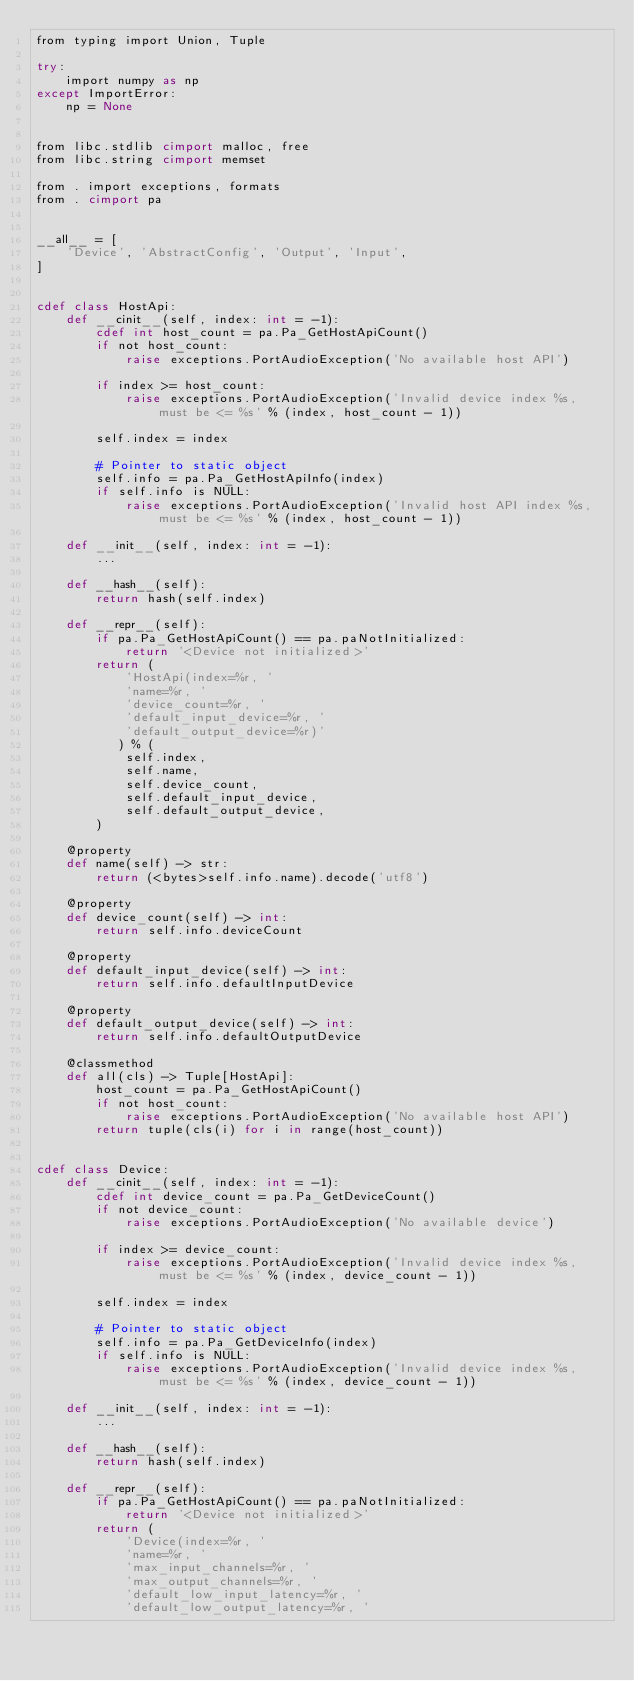<code> <loc_0><loc_0><loc_500><loc_500><_Cython_>from typing import Union, Tuple

try:
    import numpy as np
except ImportError:
    np = None


from libc.stdlib cimport malloc, free
from libc.string cimport memset

from . import exceptions, formats
from . cimport pa


__all__ = [
    'Device', 'AbstractConfig', 'Output', 'Input',
]


cdef class HostApi:
    def __cinit__(self, index: int = -1):
        cdef int host_count = pa.Pa_GetHostApiCount()
        if not host_count:
            raise exceptions.PortAudioException('No available host API')

        if index >= host_count:
            raise exceptions.PortAudioException('Invalid device index %s, must be <= %s' % (index, host_count - 1))

        self.index = index

        # Pointer to static object
        self.info = pa.Pa_GetHostApiInfo(index)
        if self.info is NULL:
            raise exceptions.PortAudioException('Invalid host API index %s, must be <= %s' % (index, host_count - 1))

    def __init__(self, index: int = -1):
        ...

    def __hash__(self):
        return hash(self.index)

    def __repr__(self):
        if pa.Pa_GetHostApiCount() == pa.paNotInitialized:
            return '<Device not initialized>'
        return (
            'HostApi(index=%r, '
            'name=%r, '
            'device_count=%r, '
            'default_input_device=%r, '
            'default_output_device=%r)'
           ) % (
            self.index,
            self.name,
            self.device_count,
            self.default_input_device,
            self.default_output_device,
        )

    @property
    def name(self) -> str:
        return (<bytes>self.info.name).decode('utf8')

    @property
    def device_count(self) -> int:
        return self.info.deviceCount

    @property
    def default_input_device(self) -> int:
        return self.info.defaultInputDevice

    @property
    def default_output_device(self) -> int:
        return self.info.defaultOutputDevice

    @classmethod
    def all(cls) -> Tuple[HostApi]:
        host_count = pa.Pa_GetHostApiCount()
        if not host_count:
            raise exceptions.PortAudioException('No available host API')
        return tuple(cls(i) for i in range(host_count))


cdef class Device:
    def __cinit__(self, index: int = -1):
        cdef int device_count = pa.Pa_GetDeviceCount()
        if not device_count:
            raise exceptions.PortAudioException('No available device')

        if index >= device_count:
            raise exceptions.PortAudioException('Invalid device index %s, must be <= %s' % (index, device_count - 1))

        self.index = index

        # Pointer to static object
        self.info = pa.Pa_GetDeviceInfo(index)
        if self.info is NULL:
            raise exceptions.PortAudioException('Invalid device index %s, must be <= %s' % (index, device_count - 1))

    def __init__(self, index: int = -1):
        ...

    def __hash__(self):
        return hash(self.index)

    def __repr__(self):
        if pa.Pa_GetHostApiCount() == pa.paNotInitialized:
            return '<Device not initialized>'
        return (
            'Device(index=%r, '
            'name=%r, '
            'max_input_channels=%r, '
            'max_output_channels=%r, '
            'default_low_input_latency=%r, '
            'default_low_output_latency=%r, '</code> 